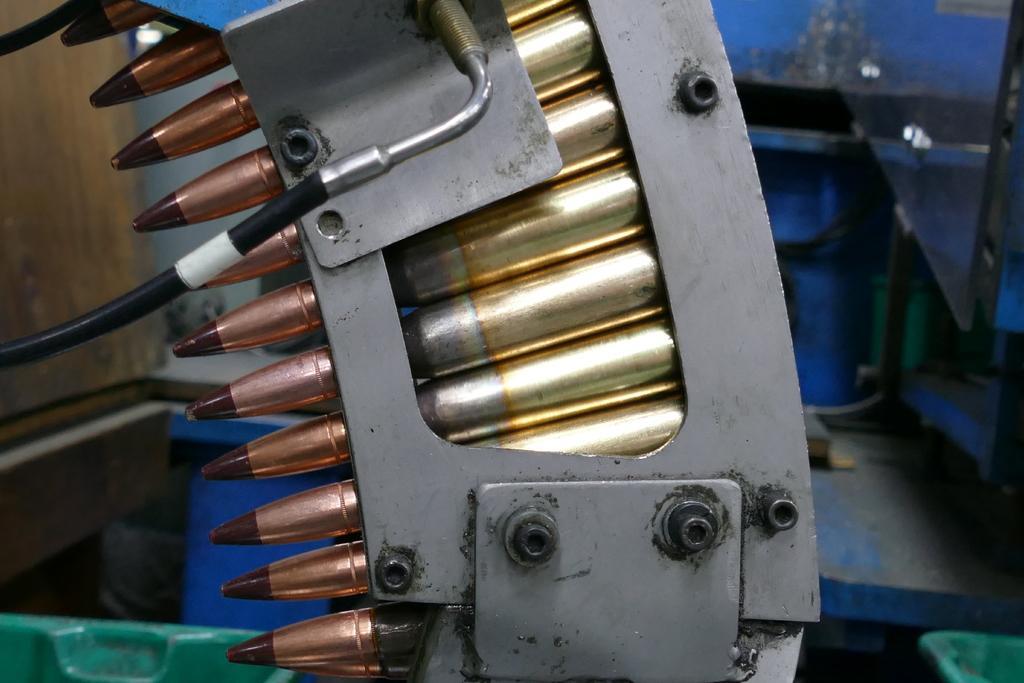Describe this image in one or two sentences. In this picture I can observe some bullets in the magazine. Bullets are in gold color. In the background I can observe a wall. 